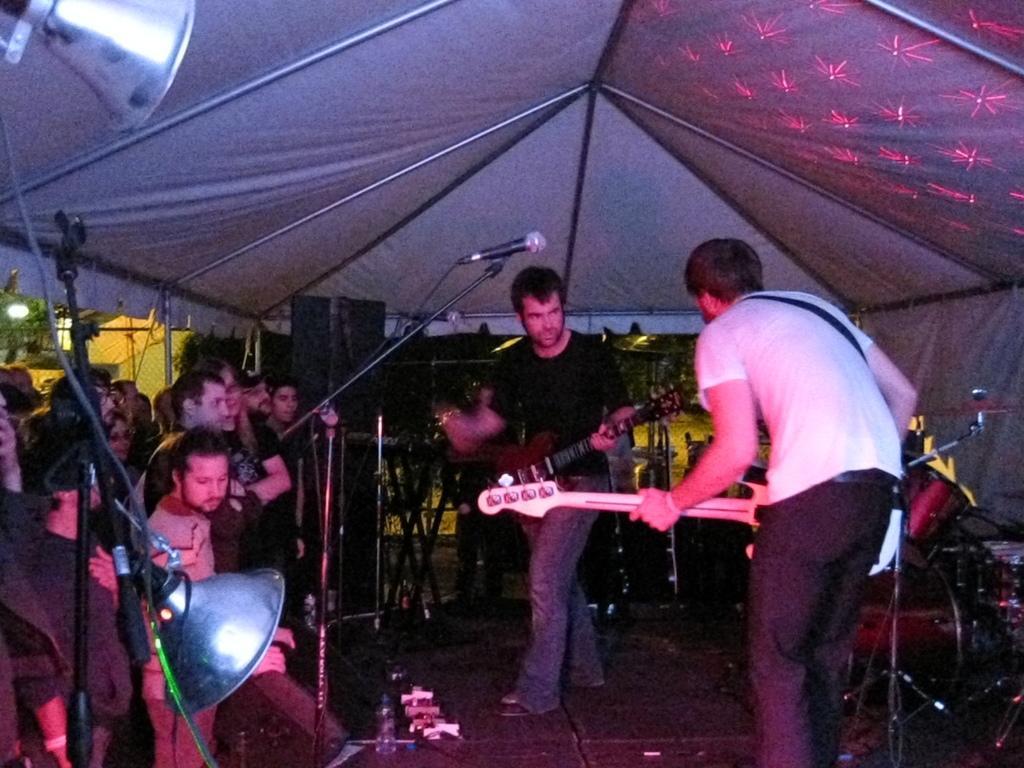How would you summarize this image in a sentence or two? In the picture we can see a two men are standing and holding a guitars and few people are standing and watching them. In the background there are some musical instruments, in front of them there is a microphone. In the ceiling there is a tent and light. 